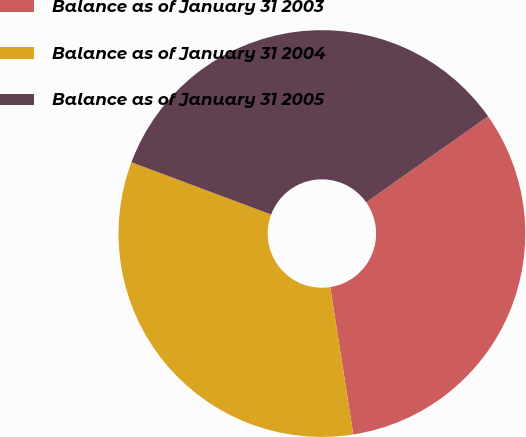Convert chart. <chart><loc_0><loc_0><loc_500><loc_500><pie_chart><fcel>Balance as of January 31 2003<fcel>Balance as of January 31 2004<fcel>Balance as of January 31 2005<nl><fcel>32.31%<fcel>33.17%<fcel>34.52%<nl></chart> 